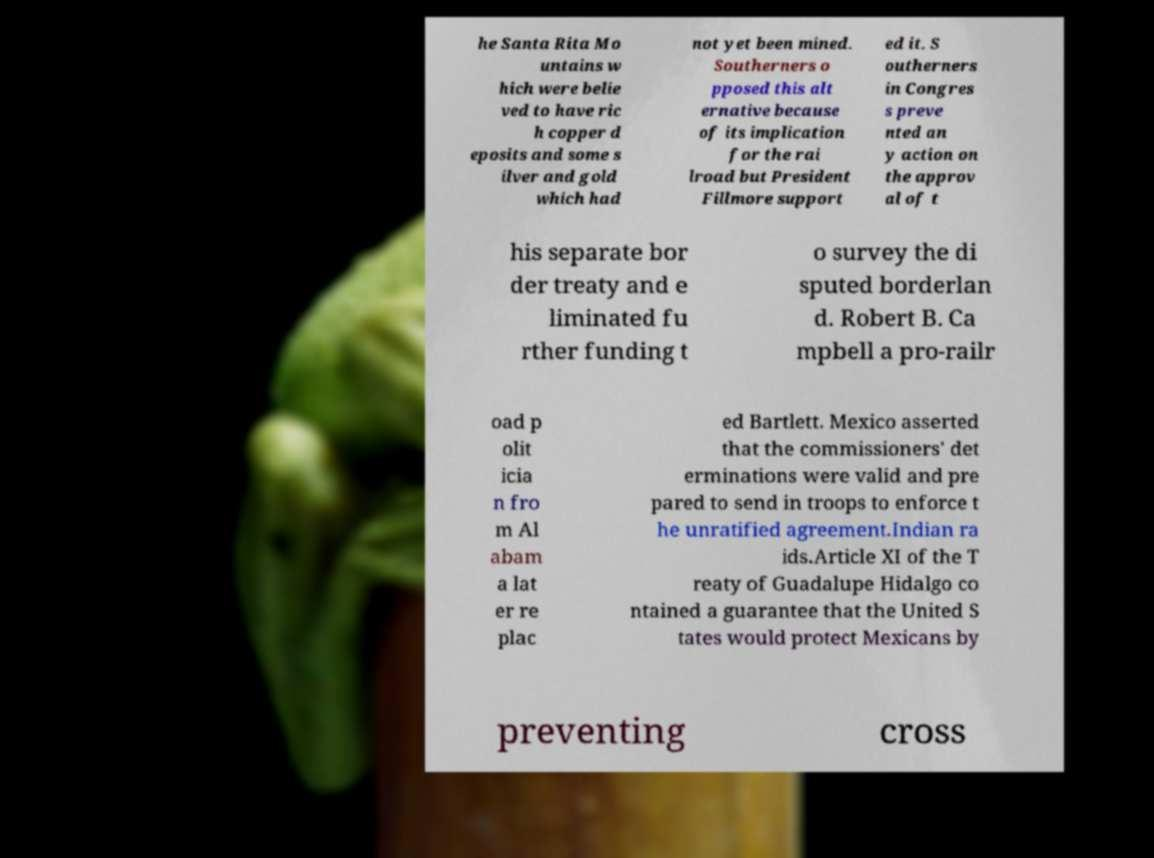Please read and relay the text visible in this image. What does it say? he Santa Rita Mo untains w hich were belie ved to have ric h copper d eposits and some s ilver and gold which had not yet been mined. Southerners o pposed this alt ernative because of its implication for the rai lroad but President Fillmore support ed it. S outherners in Congres s preve nted an y action on the approv al of t his separate bor der treaty and e liminated fu rther funding t o survey the di sputed borderlan d. Robert B. Ca mpbell a pro-railr oad p olit icia n fro m Al abam a lat er re plac ed Bartlett. Mexico asserted that the commissioners' det erminations were valid and pre pared to send in troops to enforce t he unratified agreement.Indian ra ids.Article XI of the T reaty of Guadalupe Hidalgo co ntained a guarantee that the United S tates would protect Mexicans by preventing cross 